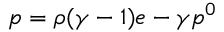Convert formula to latex. <formula><loc_0><loc_0><loc_500><loc_500>p = \rho ( \gamma - 1 ) e - \gamma p ^ { 0 }</formula> 